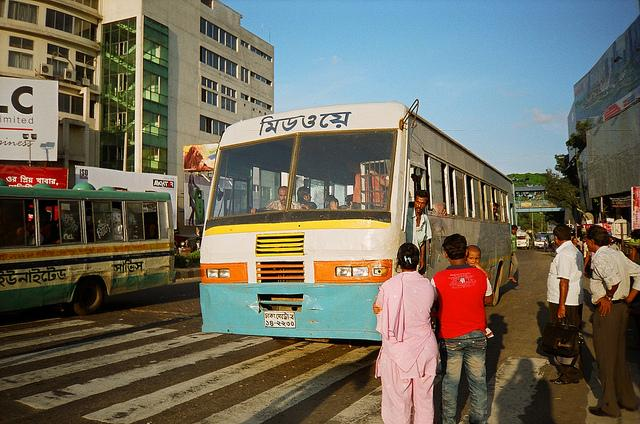What is the man with mustache about to do? Please explain your reasoning. get off. The man is about to get off the bus. 